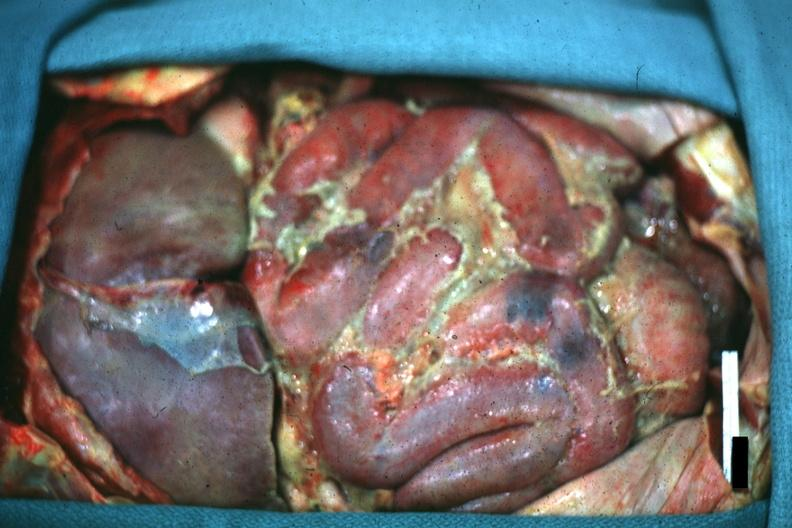where is this area in the body?
Answer the question using a single word or phrase. Abdomen 